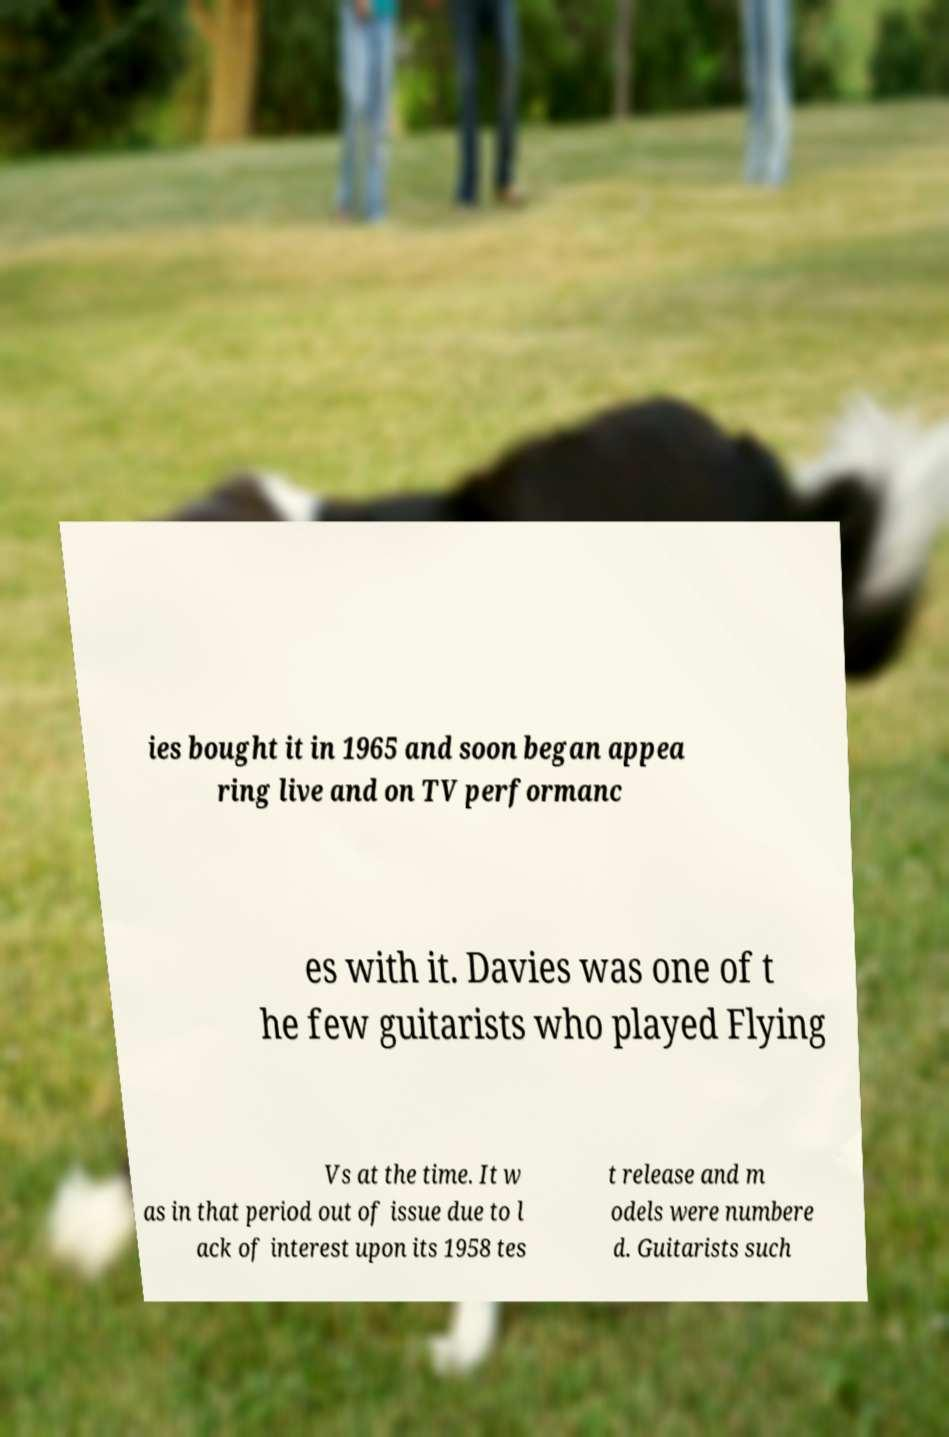Can you read and provide the text displayed in the image?This photo seems to have some interesting text. Can you extract and type it out for me? ies bought it in 1965 and soon began appea ring live and on TV performanc es with it. Davies was one of t he few guitarists who played Flying Vs at the time. It w as in that period out of issue due to l ack of interest upon its 1958 tes t release and m odels were numbere d. Guitarists such 